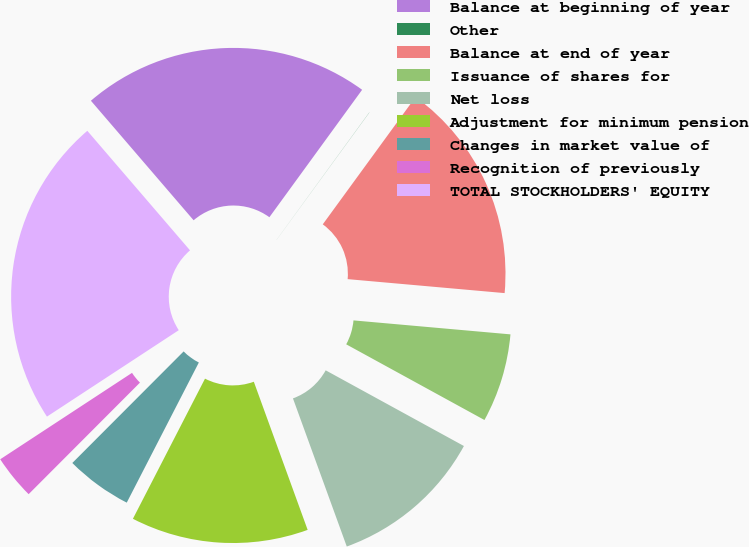Convert chart. <chart><loc_0><loc_0><loc_500><loc_500><pie_chart><fcel>Balance at beginning of year<fcel>Other<fcel>Balance at end of year<fcel>Issuance of shares for<fcel>Net loss<fcel>Adjustment for minimum pension<fcel>Changes in market value of<fcel>Recognition of previously<fcel>TOTAL STOCKHOLDERS' EQUITY<nl><fcel>21.31%<fcel>0.01%<fcel>16.39%<fcel>6.56%<fcel>11.48%<fcel>13.11%<fcel>4.92%<fcel>3.28%<fcel>22.94%<nl></chart> 